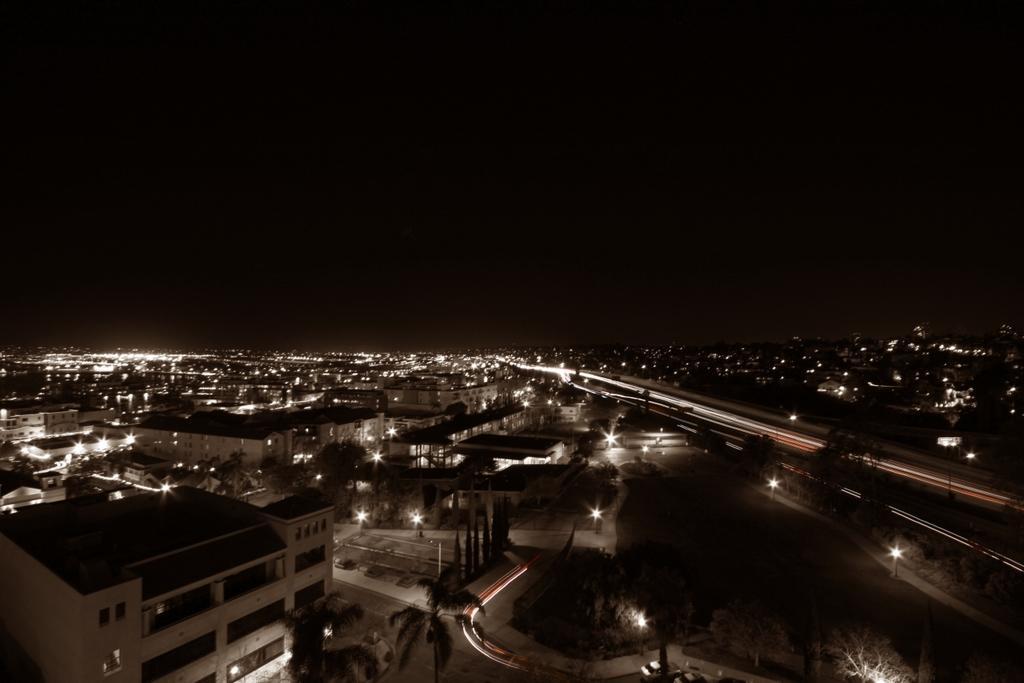Can you describe this image briefly? Here we can see buildings, trees, and lights. In the background there is sky. 